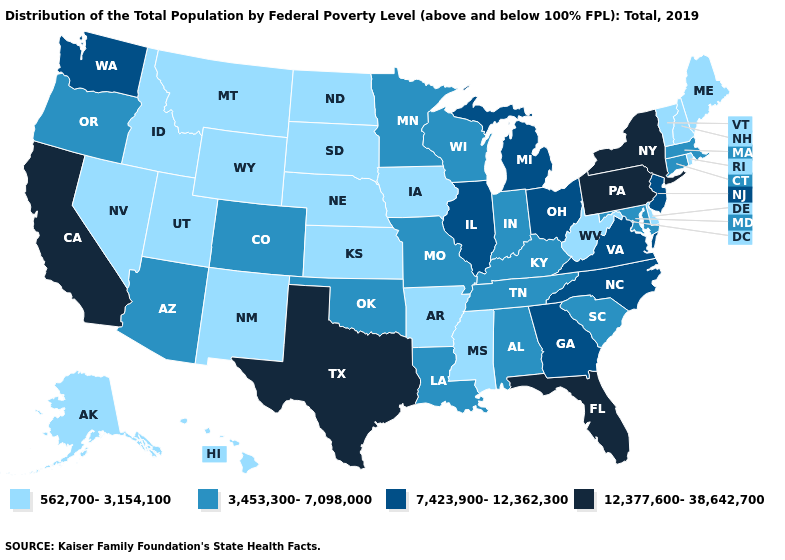What is the value of Ohio?
Keep it brief. 7,423,900-12,362,300. What is the value of Tennessee?
Keep it brief. 3,453,300-7,098,000. Name the states that have a value in the range 562,700-3,154,100?
Short answer required. Alaska, Arkansas, Delaware, Hawaii, Idaho, Iowa, Kansas, Maine, Mississippi, Montana, Nebraska, Nevada, New Hampshire, New Mexico, North Dakota, Rhode Island, South Dakota, Utah, Vermont, West Virginia, Wyoming. What is the highest value in the USA?
Concise answer only. 12,377,600-38,642,700. Does Hawaii have the lowest value in the West?
Keep it brief. Yes. What is the lowest value in states that border Illinois?
Short answer required. 562,700-3,154,100. Name the states that have a value in the range 562,700-3,154,100?
Answer briefly. Alaska, Arkansas, Delaware, Hawaii, Idaho, Iowa, Kansas, Maine, Mississippi, Montana, Nebraska, Nevada, New Hampshire, New Mexico, North Dakota, Rhode Island, South Dakota, Utah, Vermont, West Virginia, Wyoming. What is the value of Massachusetts?
Quick response, please. 3,453,300-7,098,000. Does West Virginia have a lower value than Virginia?
Write a very short answer. Yes. What is the highest value in the Northeast ?
Give a very brief answer. 12,377,600-38,642,700. Is the legend a continuous bar?
Answer briefly. No. Is the legend a continuous bar?
Write a very short answer. No. How many symbols are there in the legend?
Concise answer only. 4. Does Maryland have the same value as Rhode Island?
Short answer required. No. Does the map have missing data?
Answer briefly. No. 